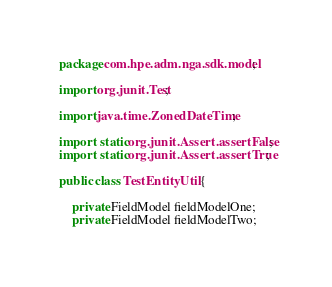Convert code to text. <code><loc_0><loc_0><loc_500><loc_500><_Java_>package com.hpe.adm.nga.sdk.model;

import org.junit.Test;

import java.time.ZonedDateTime;

import static org.junit.Assert.assertFalse;
import static org.junit.Assert.assertTrue;

public class TestEntityUtil {

    private FieldModel fieldModelOne;
    private FieldModel fieldModelTwo;
</code> 